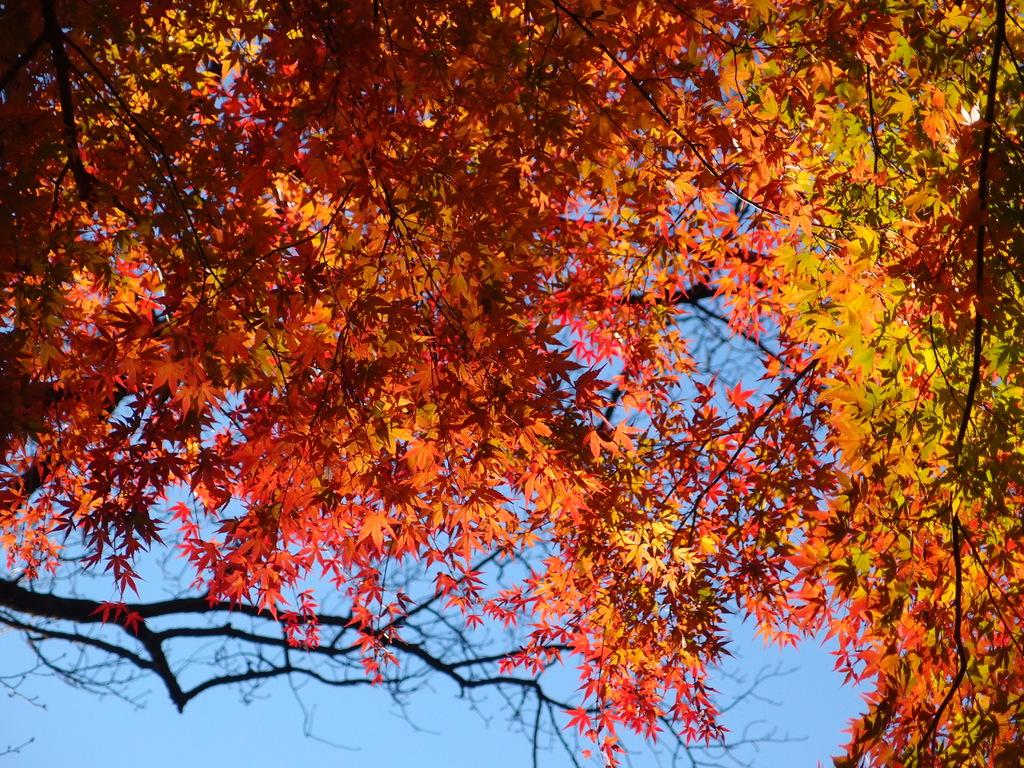What type of vegetation is visible in the front of the image? There are leaves and branches in the front of the image. What can be seen in the background of the image? The sky is visible in the background of the image. What type of behavior does the brother exhibit in the image? There is no brother present in the image, so it is not possible to determine any behavior. How many wings can be seen on the leaves in the image? Leaves do not have wings; they are part of the plant's structure and do not possess any appendages like wings. 